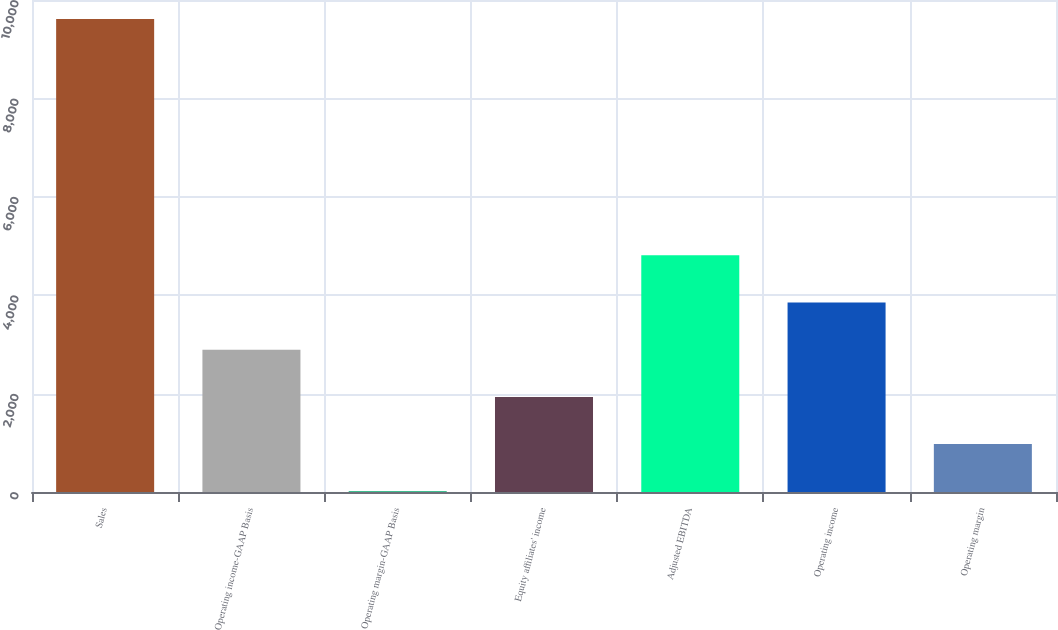Convert chart. <chart><loc_0><loc_0><loc_500><loc_500><bar_chart><fcel>Sales<fcel>Operating income-GAAP Basis<fcel>Operating margin-GAAP Basis<fcel>Equity affiliates' income<fcel>Adjusted EBITDA<fcel>Operating income<fcel>Operating margin<nl><fcel>9611.7<fcel>2892.82<fcel>13.3<fcel>1932.98<fcel>4812.5<fcel>3852.66<fcel>973.14<nl></chart> 